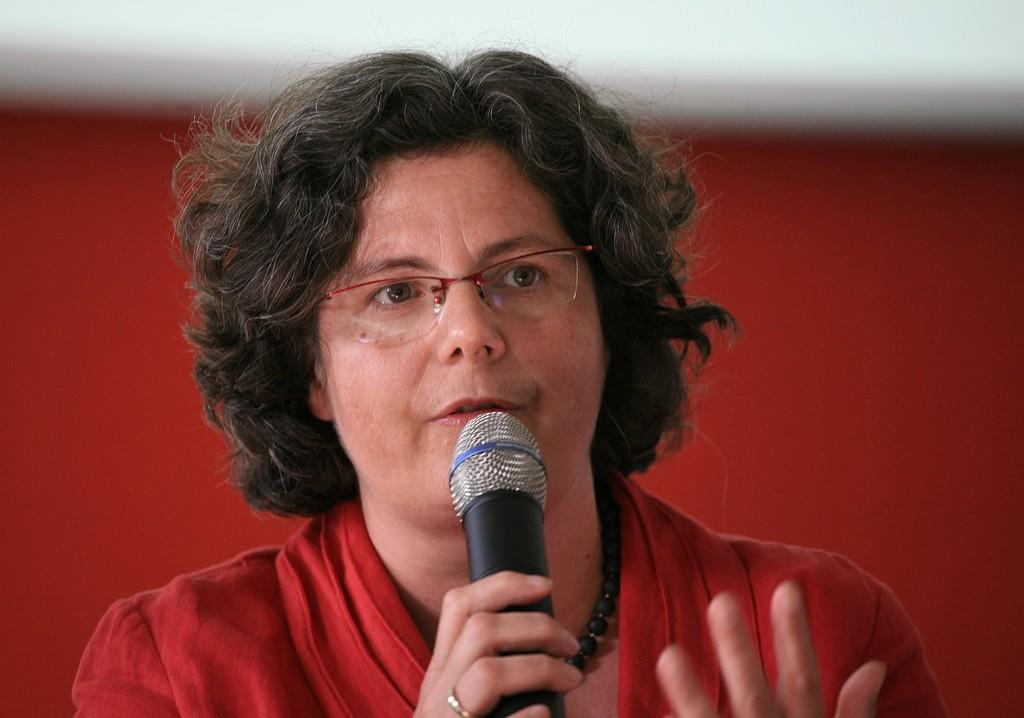Who is the main subject in the image? There is a woman in the image. What is the woman holding in the image? The woman is holding a mic. What accessory is the woman wearing in the image? The woman is wearing glasses (specs). What color is the woman's top in the image? The woman is wearing a red top. Is the woman's brother involved in a war in the field, as depicted in the image? There is no mention of a brother, war, or field in the image. The image only shows a woman holding a mic, wearing glasses, and wearing a red top. 